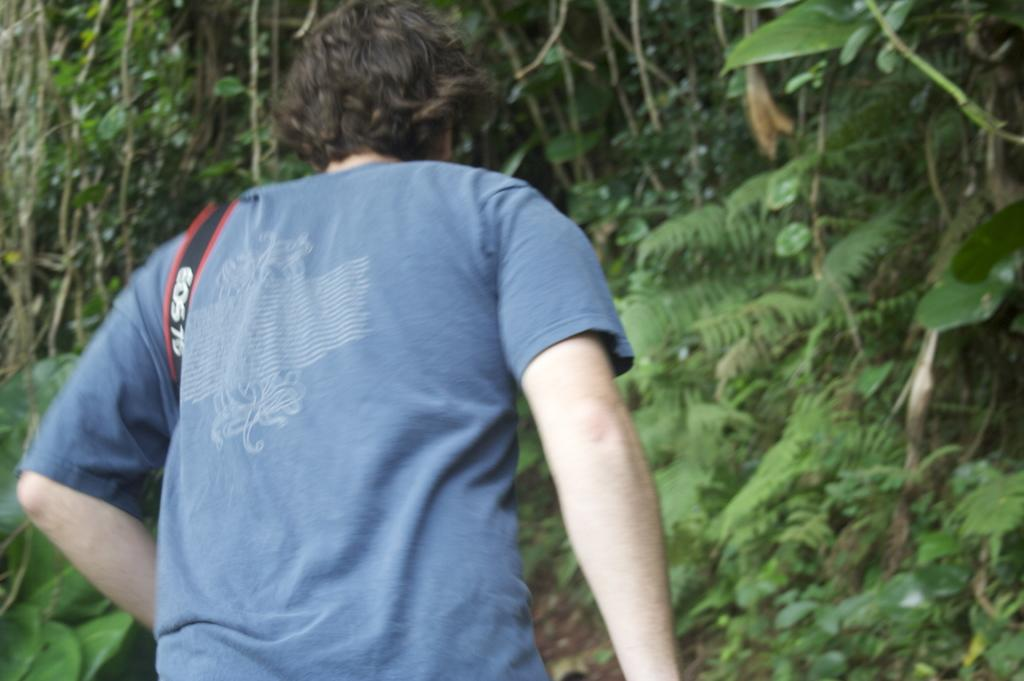Who or what is present in the image? There is a person in the image. What is the person wearing? The person is wearing a blue dress. What type of natural elements can be seen in the image? There are trees in the image. What is the color of the trees? The trees are green in color. What type of cabbage can be seen growing near the person in the image? There is no cabbage present in the image; only a person and trees are visible. Is there a ball being used by the person in the image? There is no ball visible in the image. 